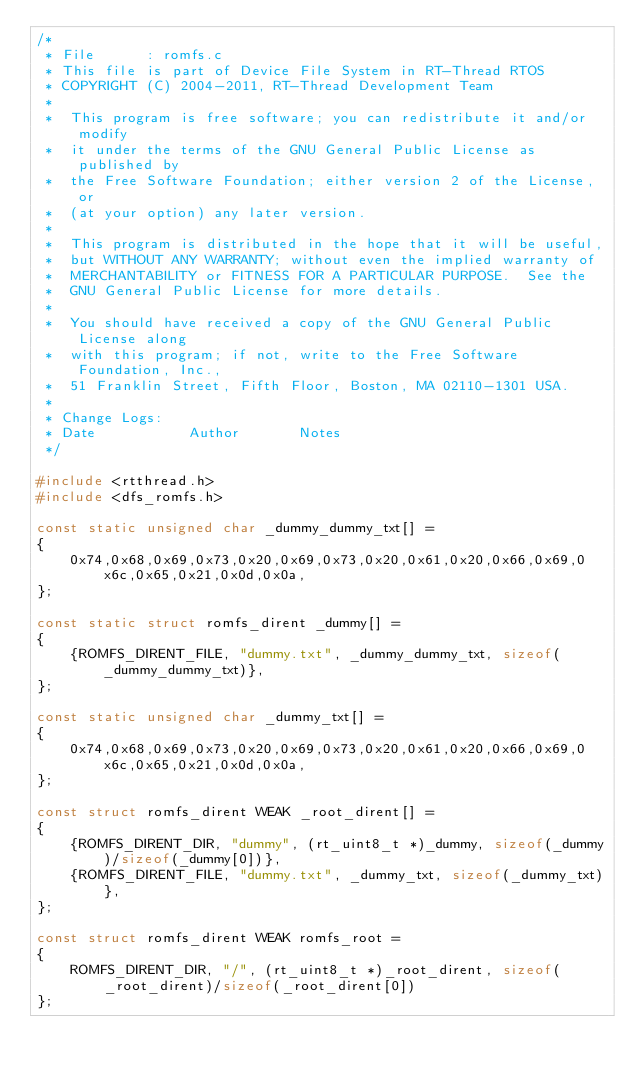Convert code to text. <code><loc_0><loc_0><loc_500><loc_500><_C_>/*
 * File      : romfs.c
 * This file is part of Device File System in RT-Thread RTOS
 * COPYRIGHT (C) 2004-2011, RT-Thread Development Team
 *
 *  This program is free software; you can redistribute it and/or modify
 *  it under the terms of the GNU General Public License as published by
 *  the Free Software Foundation; either version 2 of the License, or
 *  (at your option) any later version.
 *
 *  This program is distributed in the hope that it will be useful,
 *  but WITHOUT ANY WARRANTY; without even the implied warranty of
 *  MERCHANTABILITY or FITNESS FOR A PARTICULAR PURPOSE.  See the
 *  GNU General Public License for more details.
 *
 *  You should have received a copy of the GNU General Public License along
 *  with this program; if not, write to the Free Software Foundation, Inc.,
 *  51 Franklin Street, Fifth Floor, Boston, MA 02110-1301 USA.
 *
 * Change Logs:
 * Date           Author       Notes
 */

#include <rtthread.h>
#include <dfs_romfs.h>

const static unsigned char _dummy_dummy_txt[] =
{
    0x74,0x68,0x69,0x73,0x20,0x69,0x73,0x20,0x61,0x20,0x66,0x69,0x6c,0x65,0x21,0x0d,0x0a,
};

const static struct romfs_dirent _dummy[] =
{
    {ROMFS_DIRENT_FILE, "dummy.txt", _dummy_dummy_txt, sizeof(_dummy_dummy_txt)},
};

const static unsigned char _dummy_txt[] =
{
    0x74,0x68,0x69,0x73,0x20,0x69,0x73,0x20,0x61,0x20,0x66,0x69,0x6c,0x65,0x21,0x0d,0x0a,
};

const struct romfs_dirent WEAK _root_dirent[] =
{
    {ROMFS_DIRENT_DIR, "dummy", (rt_uint8_t *)_dummy, sizeof(_dummy)/sizeof(_dummy[0])},
    {ROMFS_DIRENT_FILE, "dummy.txt", _dummy_txt, sizeof(_dummy_txt)},
};

const struct romfs_dirent WEAK romfs_root =
{
    ROMFS_DIRENT_DIR, "/", (rt_uint8_t *)_root_dirent, sizeof(_root_dirent)/sizeof(_root_dirent[0])
};

</code> 